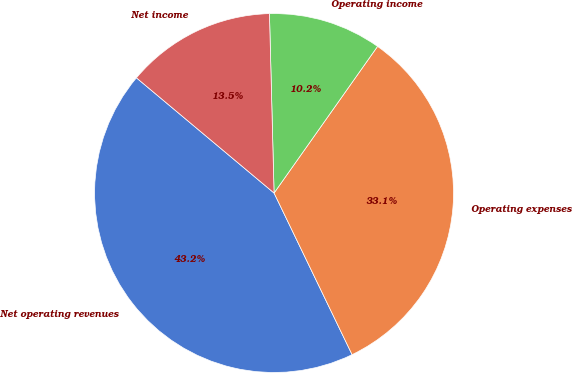Convert chart to OTSL. <chart><loc_0><loc_0><loc_500><loc_500><pie_chart><fcel>Net operating revenues<fcel>Operating expenses<fcel>Operating income<fcel>Net income<nl><fcel>43.25%<fcel>33.06%<fcel>10.19%<fcel>13.5%<nl></chart> 